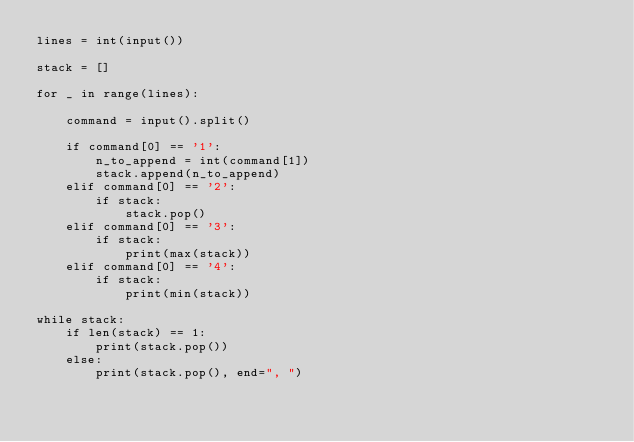Convert code to text. <code><loc_0><loc_0><loc_500><loc_500><_Python_>lines = int(input())

stack = []

for _ in range(lines):

    command = input().split()

    if command[0] == '1':
        n_to_append = int(command[1])
        stack.append(n_to_append)
    elif command[0] == '2':
        if stack:
            stack.pop()
    elif command[0] == '3':
        if stack:
            print(max(stack))
    elif command[0] == '4':
        if stack:
            print(min(stack))

while stack:
    if len(stack) == 1:
        print(stack.pop())
    else:
        print(stack.pop(), end=", ")</code> 